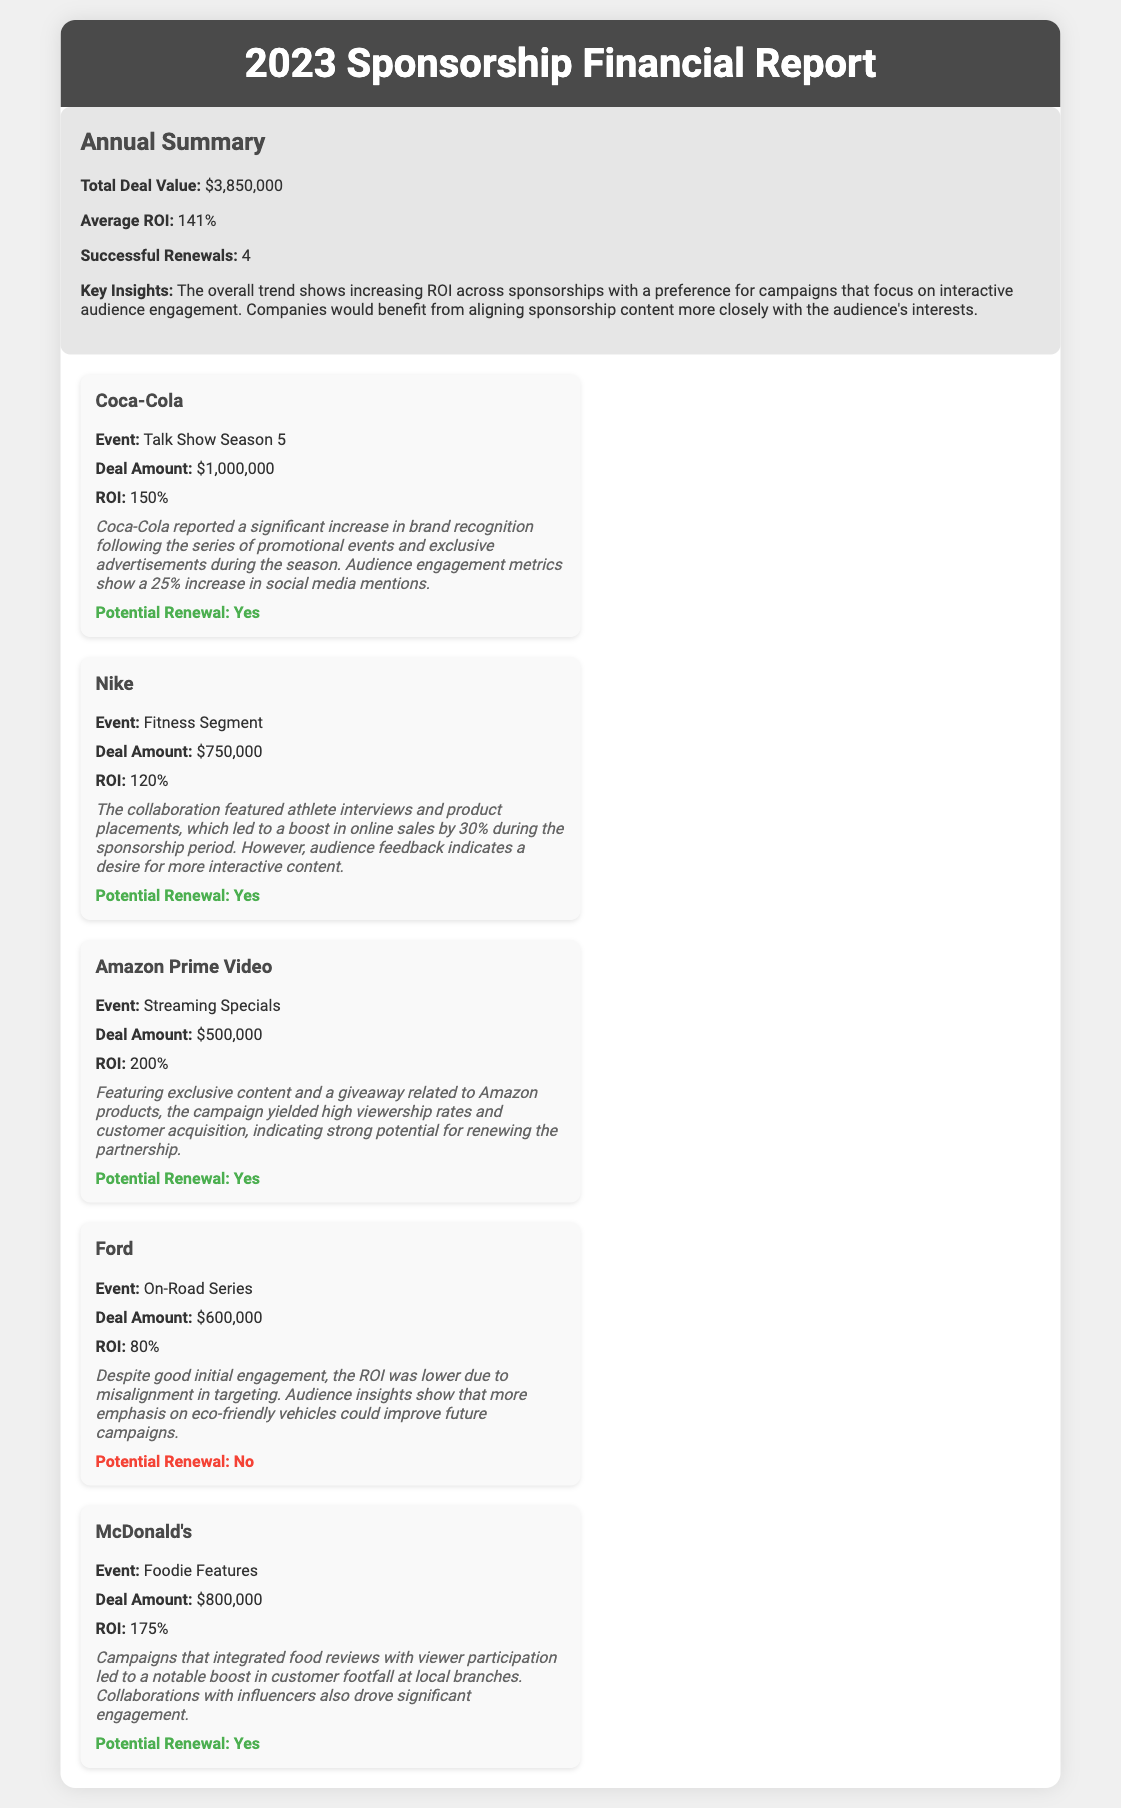What is the total deal value? The total deal value is listed in the annual summary section of the document.
Answer: $3,850,000 What is the average ROI? The average ROI is stated in the annual summary section of the report.
Answer: 141% Which sponsor had the highest ROI? The sponsor with the highest ROI can be determined by comparing the ROI figures in the deal sections.
Answer: Amazon Prime Video How much did Nike invest? The investment amount for Nike is provided within the sponsorship deal information.
Answer: $750,000 Is Ford eligible for renewal? The eligibility for renewal is indicated in the potential renewal section under Ford's sponsorship deal.
Answer: No What event was associated with Coca-Cola? The event related to Coca-Cola is mentioned in the deal section focusing on that sponsor.
Answer: Talk Show Season 5 How many successful renewals were recorded? The number of successful renewals is mentioned in the annual summary.
Answer: 4 What was the deal amount for McDonald's? The deal amount for McDonald's is detailed in the specific sponsorship section for this sponsor.
Answer: $800,000 What strategy helped Amazon Prime Video's ROI? The insights section provides reasoning on how the campaign led to a high ROI for Amazon Prime Video.
Answer: Exclusive content and a giveaway 